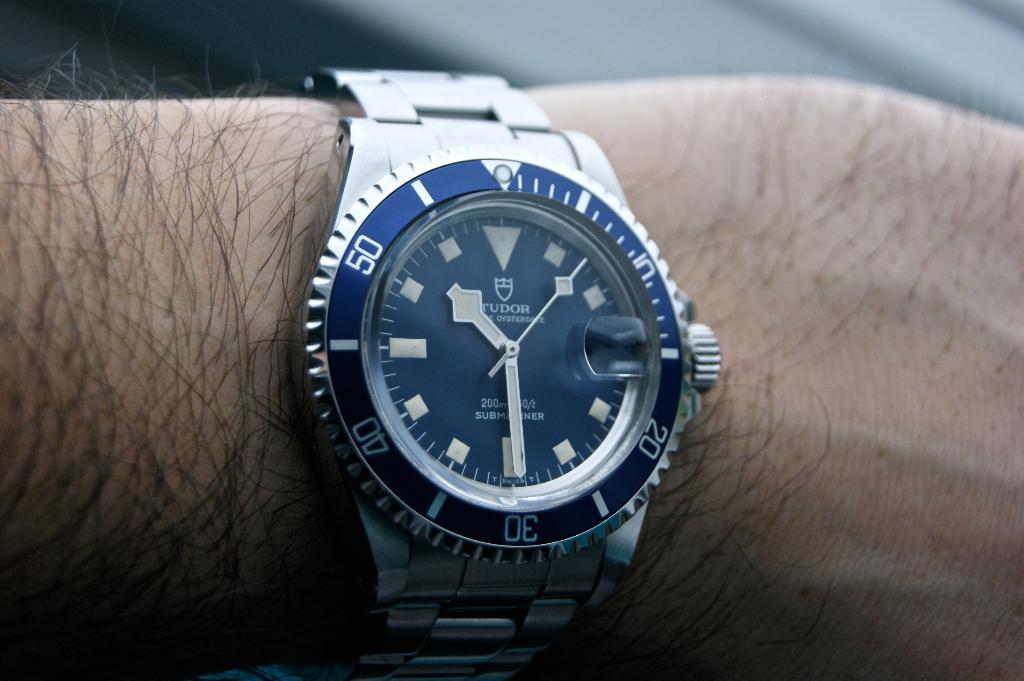What is the brand name?
Keep it short and to the point. Tudor. 